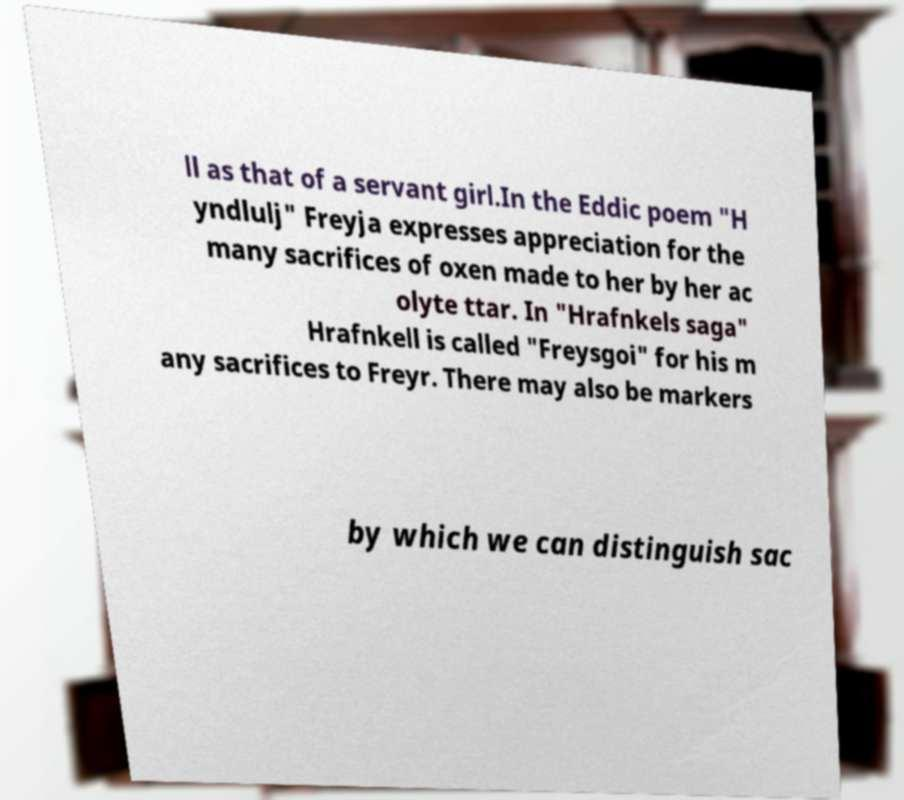Can you read and provide the text displayed in the image?This photo seems to have some interesting text. Can you extract and type it out for me? ll as that of a servant girl.In the Eddic poem "H yndlulj" Freyja expresses appreciation for the many sacrifices of oxen made to her by her ac olyte ttar. In "Hrafnkels saga" Hrafnkell is called "Freysgoi" for his m any sacrifices to Freyr. There may also be markers by which we can distinguish sac 